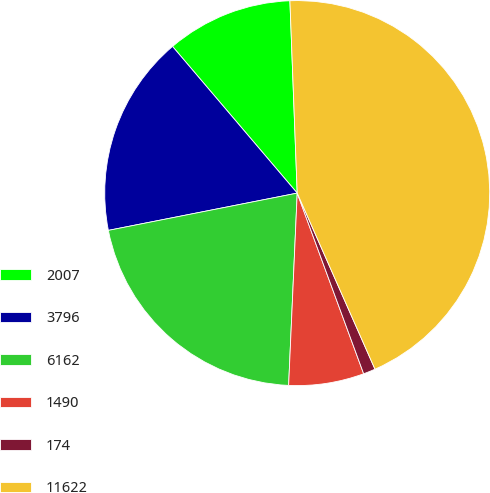Convert chart to OTSL. <chart><loc_0><loc_0><loc_500><loc_500><pie_chart><fcel>2007<fcel>3796<fcel>6162<fcel>1490<fcel>174<fcel>11622<nl><fcel>10.61%<fcel>16.89%<fcel>21.19%<fcel>6.32%<fcel>1.01%<fcel>43.99%<nl></chart> 